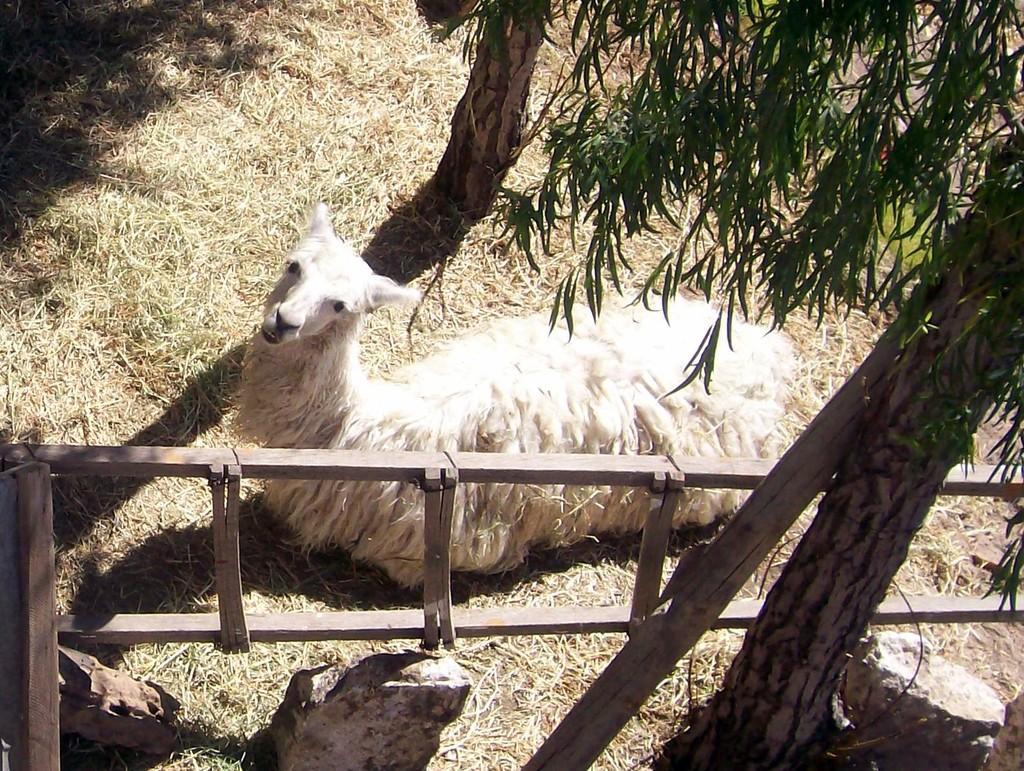How would you summarize this image in a sentence or two? In the picture there is an animal lying on the grass and there are two trees on either side of the animal. 